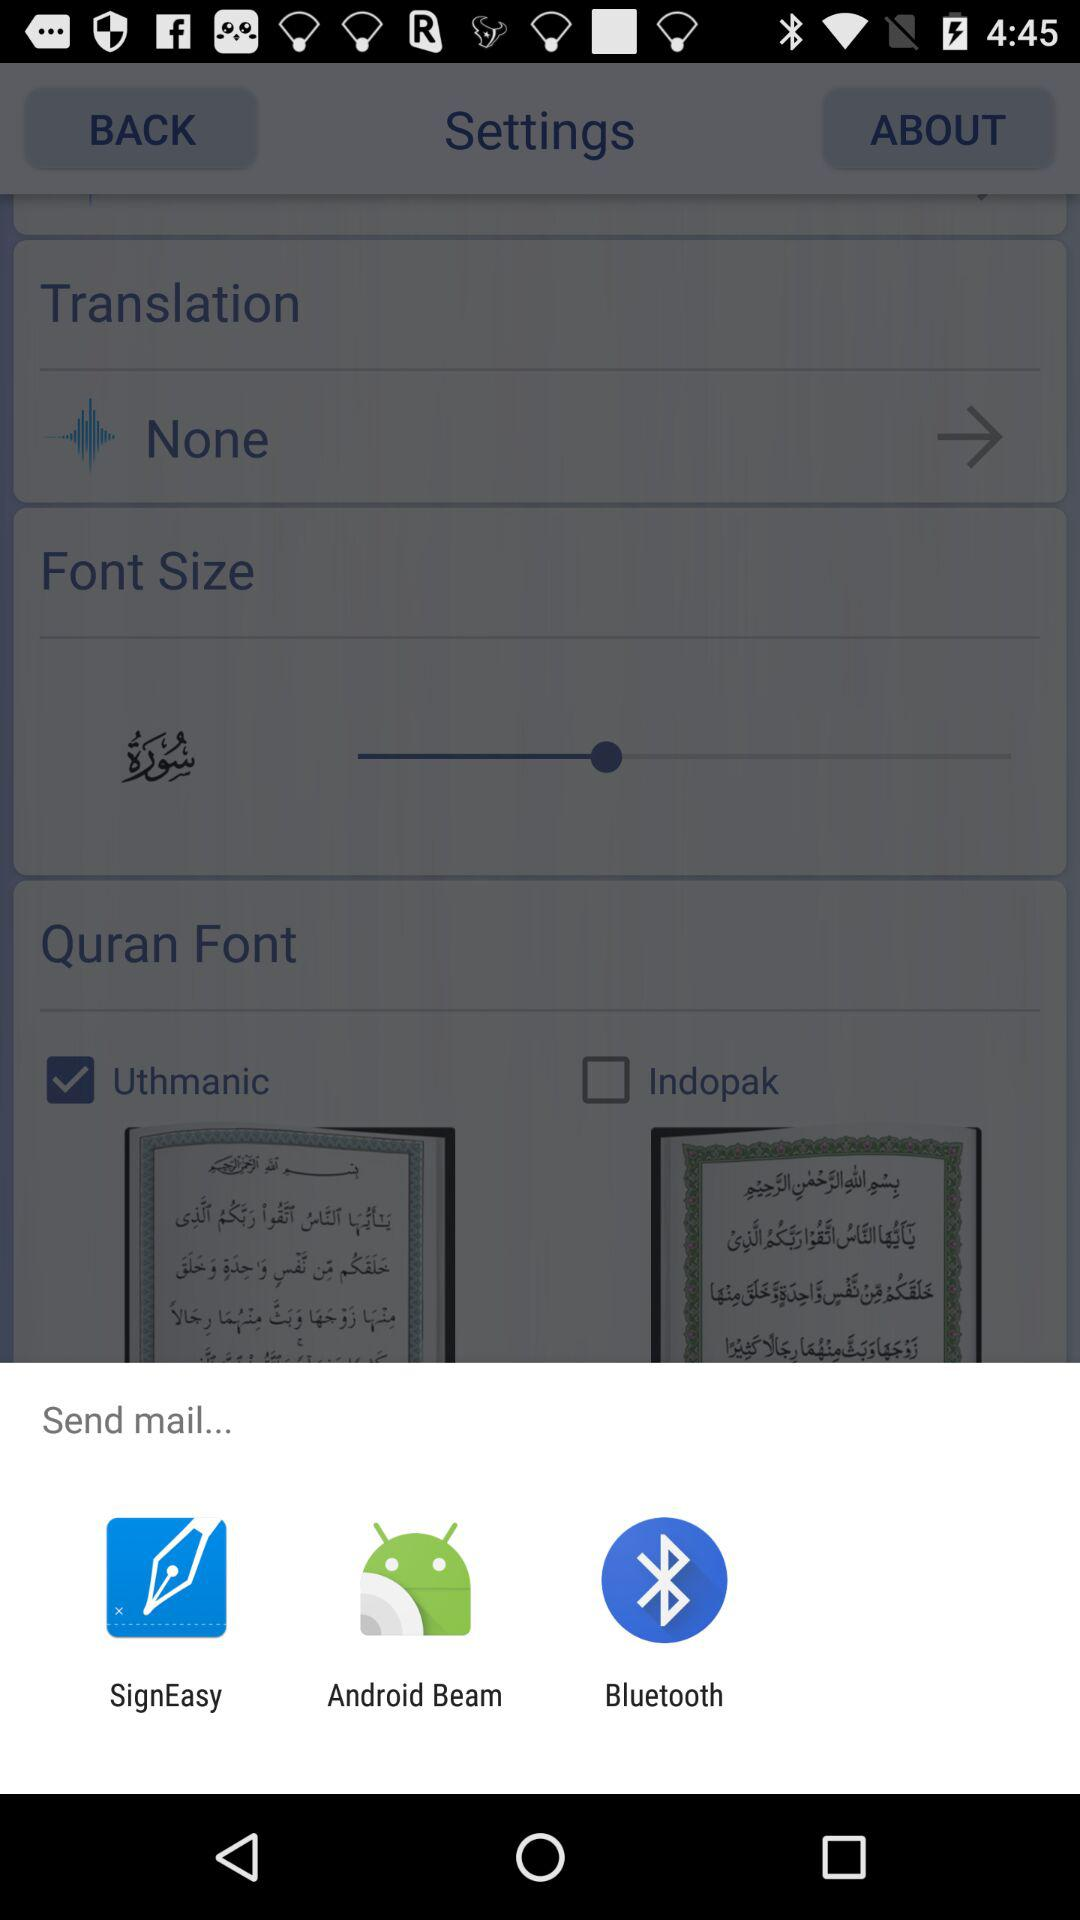Which are the different sending options? The different sending options are "SignEasy", "Android Beam" and "Bluetooth". 